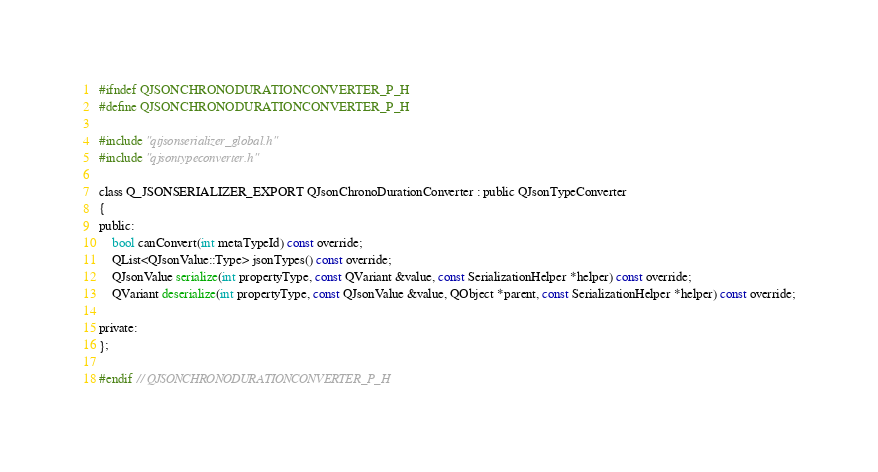Convert code to text. <code><loc_0><loc_0><loc_500><loc_500><_C_>#ifndef QJSONCHRONODURATIONCONVERTER_P_H
#define QJSONCHRONODURATIONCONVERTER_P_H

#include "qtjsonserializer_global.h"
#include "qjsontypeconverter.h"

class Q_JSONSERIALIZER_EXPORT QJsonChronoDurationConverter : public QJsonTypeConverter
{
public:
	bool canConvert(int metaTypeId) const override;
	QList<QJsonValue::Type> jsonTypes() const override;
	QJsonValue serialize(int propertyType, const QVariant &value, const SerializationHelper *helper) const override;
	QVariant deserialize(int propertyType, const QJsonValue &value, QObject *parent, const SerializationHelper *helper) const override;

private:
};

#endif // QJSONCHRONODURATIONCONVERTER_P_H
</code> 